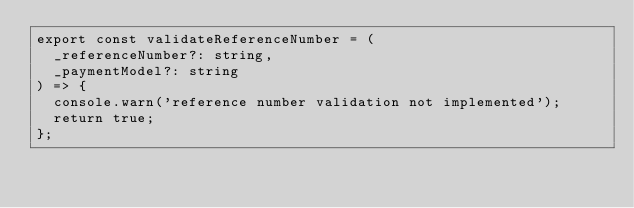Convert code to text. <code><loc_0><loc_0><loc_500><loc_500><_TypeScript_>export const validateReferenceNumber = (
  _referenceNumber?: string,
  _paymentModel?: string
) => {
  console.warn('reference number validation not implemented');
  return true;
};
</code> 